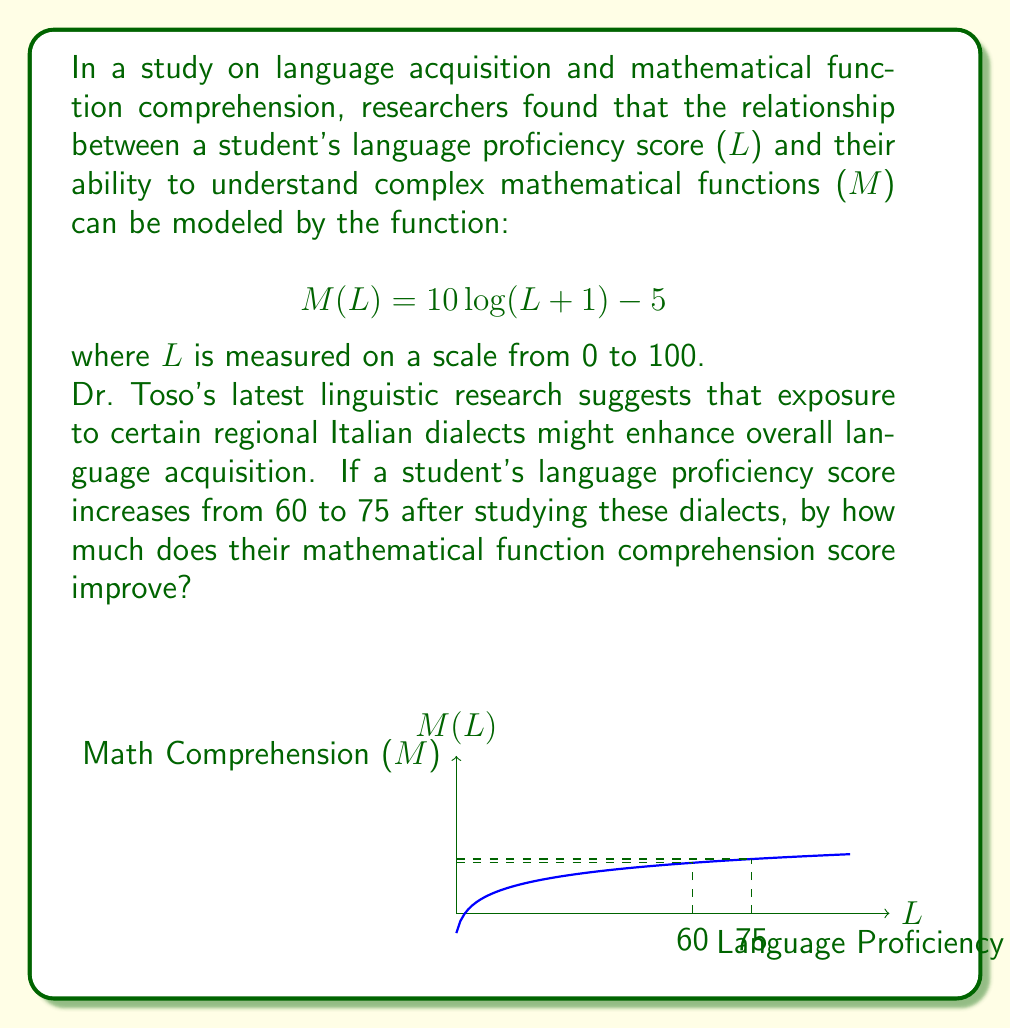Provide a solution to this math problem. Let's approach this step-by-step:

1) We need to calculate M(75) - M(60) to find the improvement in mathematical function comprehension.

2) First, let's calculate M(60):
   $$M(60) = 10 \log(60+1) - 5$$
   $$= 10 \log(61) - 5$$
   $$\approx 17.85 - 5 = 12.85$$

3) Now, let's calculate M(75):
   $$M(75) = 10 \log(75+1) - 5$$
   $$= 10 \log(76) - 5$$
   $$\approx 18.81 - 5 = 13.81$$

4) The improvement is the difference between these two values:
   $$M(75) - M(60) = 13.81 - 12.85 = 0.96$$

5) We can verify this directly:
   $$M(75) - M(60) = [10 \log(76) - 5] - [10 \log(61) - 5]$$
   $$= 10 \log(76) - 10 \log(61)$$
   $$= 10 [\log(76) - \log(61)]$$
   $$= 10 \log(\frac{76}{61})$$
   $$\approx 0.96$$

Therefore, the student's mathematical function comprehension score improves by approximately 0.96 points.
Answer: 0.96 